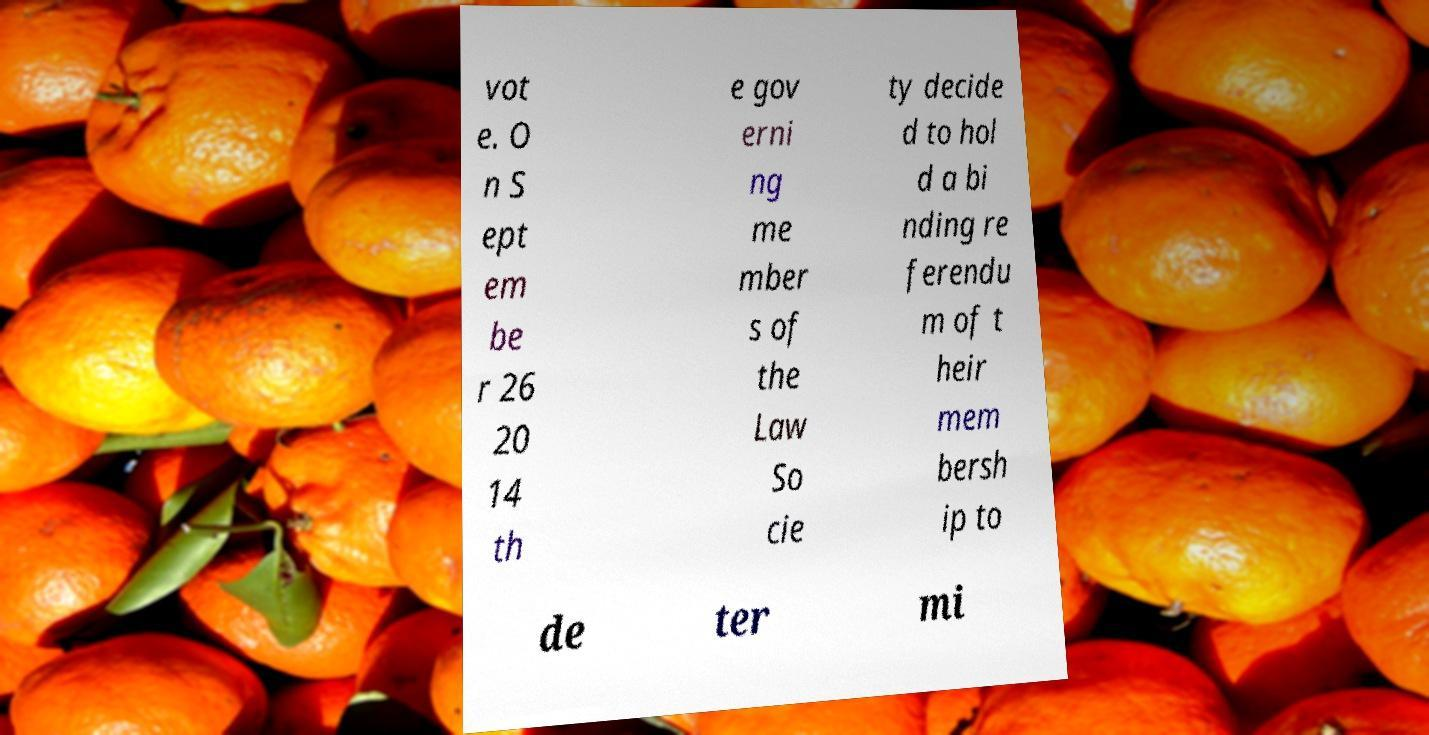Please read and relay the text visible in this image. What does it say? vot e. O n S ept em be r 26 20 14 th e gov erni ng me mber s of the Law So cie ty decide d to hol d a bi nding re ferendu m of t heir mem bersh ip to de ter mi 